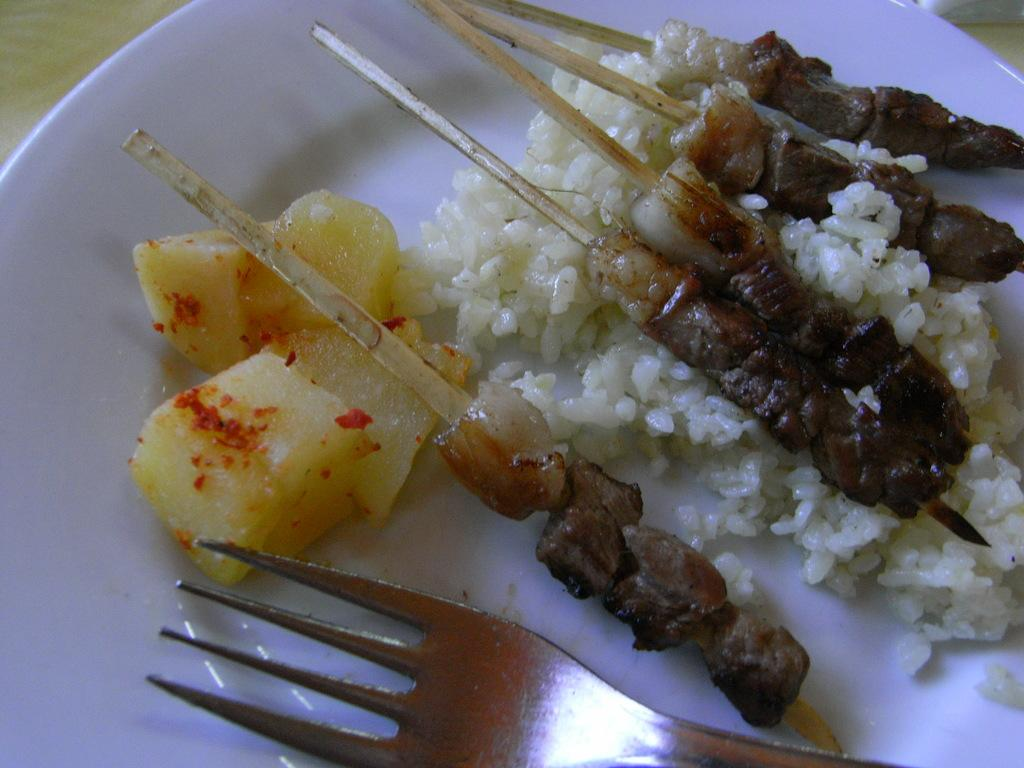What is on the plate that is visible in the image? There is food in a plate in the image. What type of food can be seen in the image? There is rice and meat in the image. What utensil is visible in the image? There is a fork visible in the image. What type of store can be seen in the background of the image? There is no store visible in the image; it only shows food on a plate with a fork. 